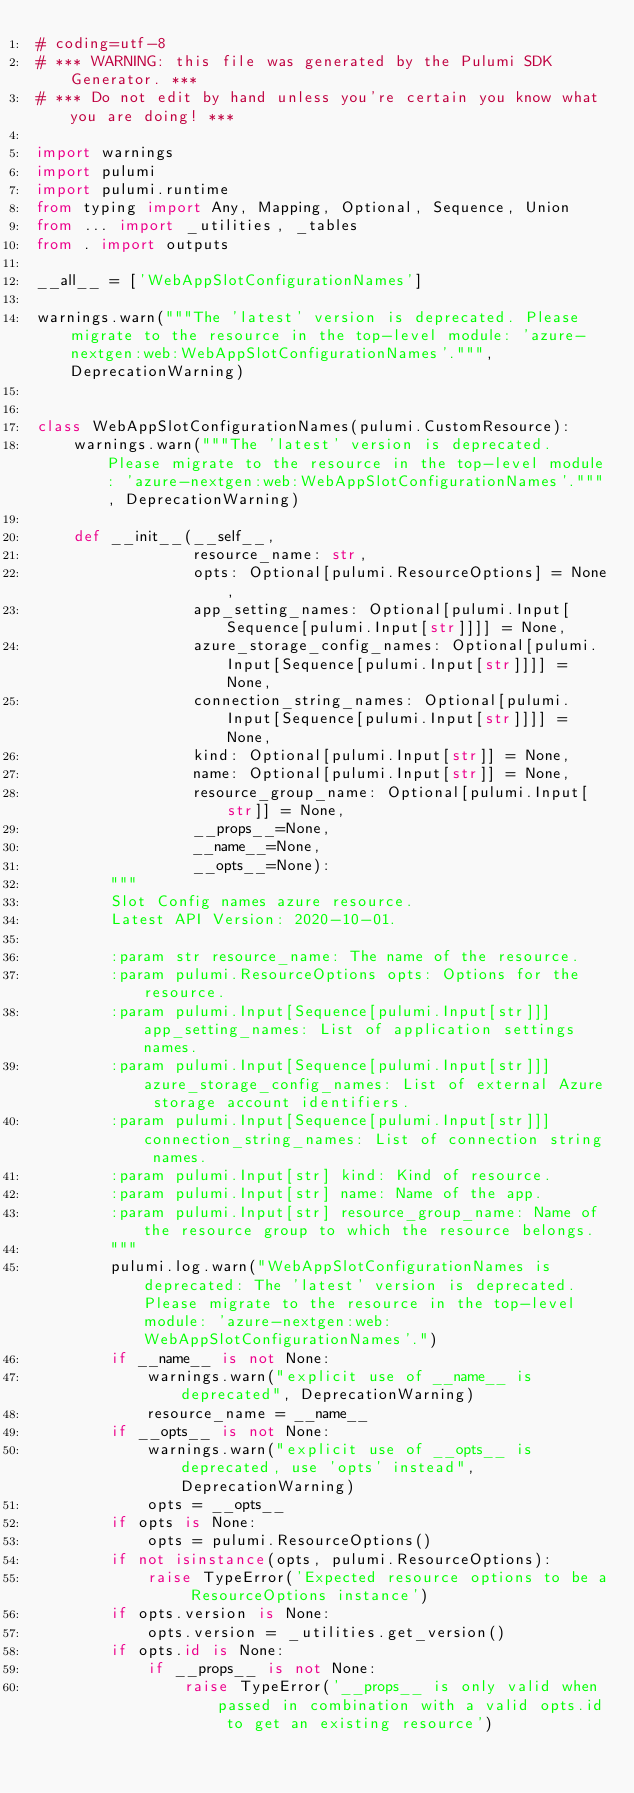<code> <loc_0><loc_0><loc_500><loc_500><_Python_># coding=utf-8
# *** WARNING: this file was generated by the Pulumi SDK Generator. ***
# *** Do not edit by hand unless you're certain you know what you are doing! ***

import warnings
import pulumi
import pulumi.runtime
from typing import Any, Mapping, Optional, Sequence, Union
from ... import _utilities, _tables
from . import outputs

__all__ = ['WebAppSlotConfigurationNames']

warnings.warn("""The 'latest' version is deprecated. Please migrate to the resource in the top-level module: 'azure-nextgen:web:WebAppSlotConfigurationNames'.""", DeprecationWarning)


class WebAppSlotConfigurationNames(pulumi.CustomResource):
    warnings.warn("""The 'latest' version is deprecated. Please migrate to the resource in the top-level module: 'azure-nextgen:web:WebAppSlotConfigurationNames'.""", DeprecationWarning)

    def __init__(__self__,
                 resource_name: str,
                 opts: Optional[pulumi.ResourceOptions] = None,
                 app_setting_names: Optional[pulumi.Input[Sequence[pulumi.Input[str]]]] = None,
                 azure_storage_config_names: Optional[pulumi.Input[Sequence[pulumi.Input[str]]]] = None,
                 connection_string_names: Optional[pulumi.Input[Sequence[pulumi.Input[str]]]] = None,
                 kind: Optional[pulumi.Input[str]] = None,
                 name: Optional[pulumi.Input[str]] = None,
                 resource_group_name: Optional[pulumi.Input[str]] = None,
                 __props__=None,
                 __name__=None,
                 __opts__=None):
        """
        Slot Config names azure resource.
        Latest API Version: 2020-10-01.

        :param str resource_name: The name of the resource.
        :param pulumi.ResourceOptions opts: Options for the resource.
        :param pulumi.Input[Sequence[pulumi.Input[str]]] app_setting_names: List of application settings names.
        :param pulumi.Input[Sequence[pulumi.Input[str]]] azure_storage_config_names: List of external Azure storage account identifiers.
        :param pulumi.Input[Sequence[pulumi.Input[str]]] connection_string_names: List of connection string names.
        :param pulumi.Input[str] kind: Kind of resource.
        :param pulumi.Input[str] name: Name of the app.
        :param pulumi.Input[str] resource_group_name: Name of the resource group to which the resource belongs.
        """
        pulumi.log.warn("WebAppSlotConfigurationNames is deprecated: The 'latest' version is deprecated. Please migrate to the resource in the top-level module: 'azure-nextgen:web:WebAppSlotConfigurationNames'.")
        if __name__ is not None:
            warnings.warn("explicit use of __name__ is deprecated", DeprecationWarning)
            resource_name = __name__
        if __opts__ is not None:
            warnings.warn("explicit use of __opts__ is deprecated, use 'opts' instead", DeprecationWarning)
            opts = __opts__
        if opts is None:
            opts = pulumi.ResourceOptions()
        if not isinstance(opts, pulumi.ResourceOptions):
            raise TypeError('Expected resource options to be a ResourceOptions instance')
        if opts.version is None:
            opts.version = _utilities.get_version()
        if opts.id is None:
            if __props__ is not None:
                raise TypeError('__props__ is only valid when passed in combination with a valid opts.id to get an existing resource')</code> 